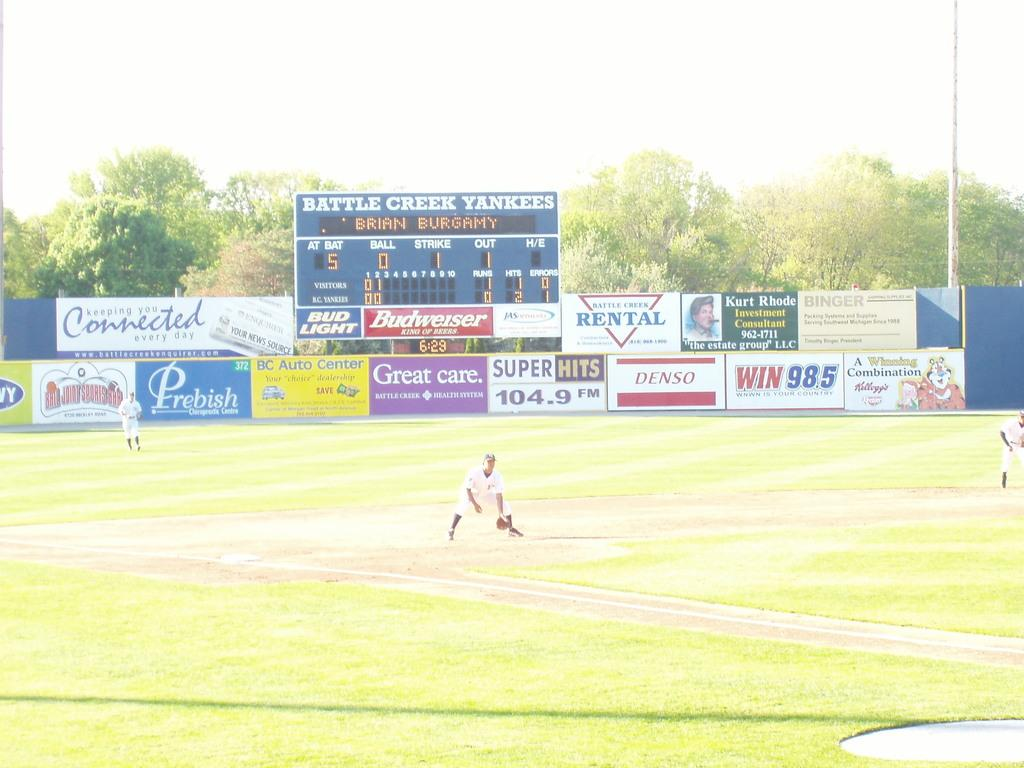Provide a one-sentence caption for the provided image. Baseball field with sponsors names and ads on a wall. 